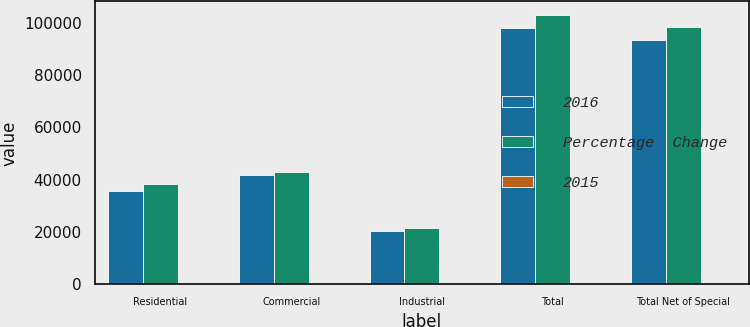Convert chart to OTSL. <chart><loc_0><loc_0><loc_500><loc_500><stacked_bar_chart><ecel><fcel>Residential<fcel>Commercial<fcel>Industrial<fcel>Total<fcel>Total Net of Special<nl><fcel>2016<fcel>35734<fcel>41895<fcel>20413<fcel>98042<fcel>93346<nl><fcel>Percentage  Change<fcel>38455<fcel>43006<fcel>21538<fcel>102999<fcel>98458<nl><fcel>2015<fcel>7.1<fcel>2.6<fcel>5.2<fcel>4.8<fcel>5.2<nl></chart> 